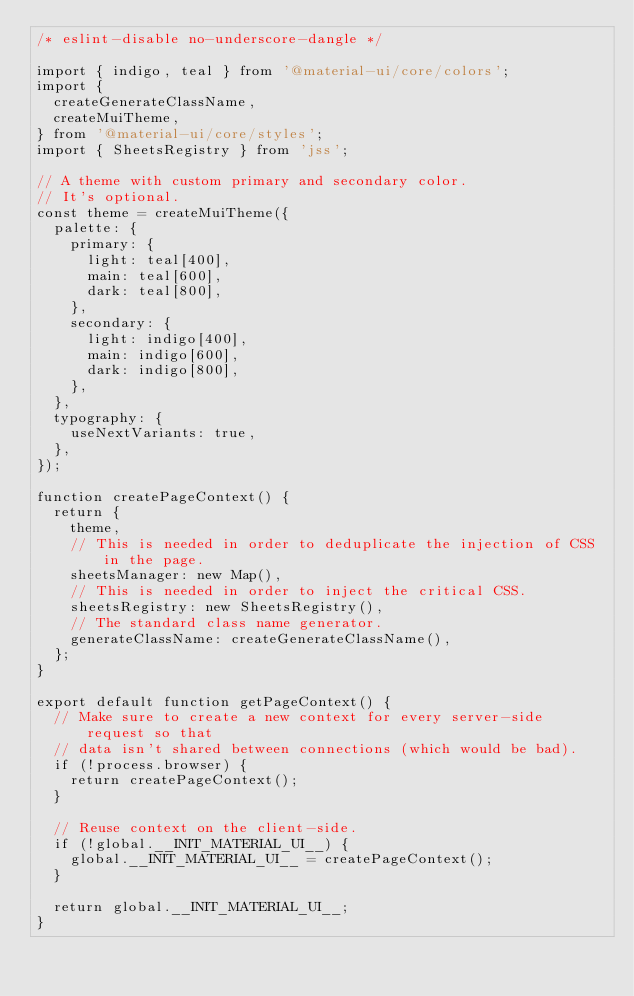<code> <loc_0><loc_0><loc_500><loc_500><_JavaScript_>/* eslint-disable no-underscore-dangle */

import { indigo, teal } from '@material-ui/core/colors';
import {
  createGenerateClassName,
  createMuiTheme,
} from '@material-ui/core/styles';
import { SheetsRegistry } from 'jss';

// A theme with custom primary and secondary color.
// It's optional.
const theme = createMuiTheme({
  palette: {
    primary: {
      light: teal[400],
      main: teal[600],
      dark: teal[800],
    },
    secondary: {
      light: indigo[400],
      main: indigo[600],
      dark: indigo[800],
    },
  },
  typography: {
    useNextVariants: true,
  },
});

function createPageContext() {
  return {
    theme,
    // This is needed in order to deduplicate the injection of CSS in the page.
    sheetsManager: new Map(),
    // This is needed in order to inject the critical CSS.
    sheetsRegistry: new SheetsRegistry(),
    // The standard class name generator.
    generateClassName: createGenerateClassName(),
  };
}

export default function getPageContext() {
  // Make sure to create a new context for every server-side request so that
  // data isn't shared between connections (which would be bad).
  if (!process.browser) {
    return createPageContext();
  }

  // Reuse context on the client-side.
  if (!global.__INIT_MATERIAL_UI__) {
    global.__INIT_MATERIAL_UI__ = createPageContext();
  }

  return global.__INIT_MATERIAL_UI__;
}
</code> 